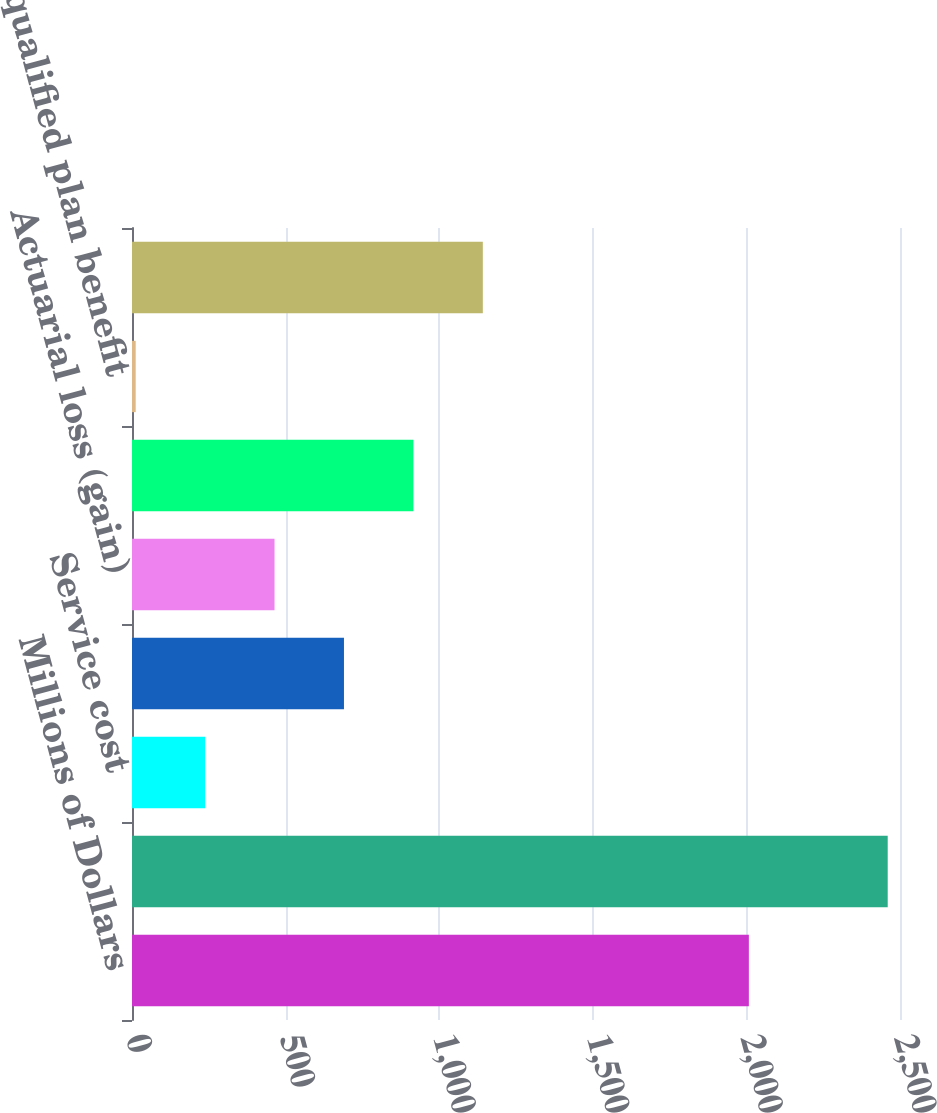Convert chart. <chart><loc_0><loc_0><loc_500><loc_500><bar_chart><fcel>Millions of Dollars<fcel>Projected benefit obligation<fcel>Service cost<fcel>Interest cost<fcel>Actuarial loss (gain)<fcel>Gross benefits paid<fcel>Non-qualified plan benefit<fcel>Funded status at end of year<nl><fcel>2008<fcel>2460<fcel>238<fcel>690<fcel>464<fcel>916<fcel>12<fcel>1142<nl></chart> 